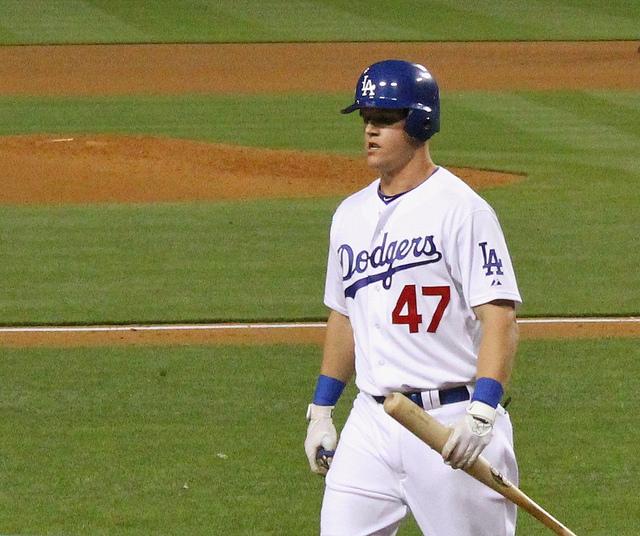What number is this player?
Answer briefly. 47. What city is this team based out of?
Concise answer only. Los angeles. Which hand is holding the bat?
Be succinct. Left. 